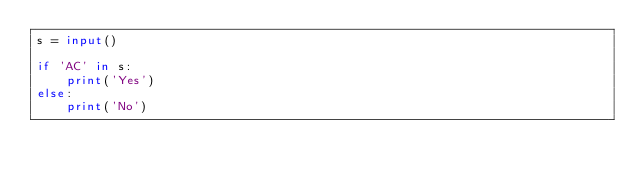<code> <loc_0><loc_0><loc_500><loc_500><_Python_>s = input()

if 'AC' in s:
    print('Yes')
else:
    print('No')</code> 